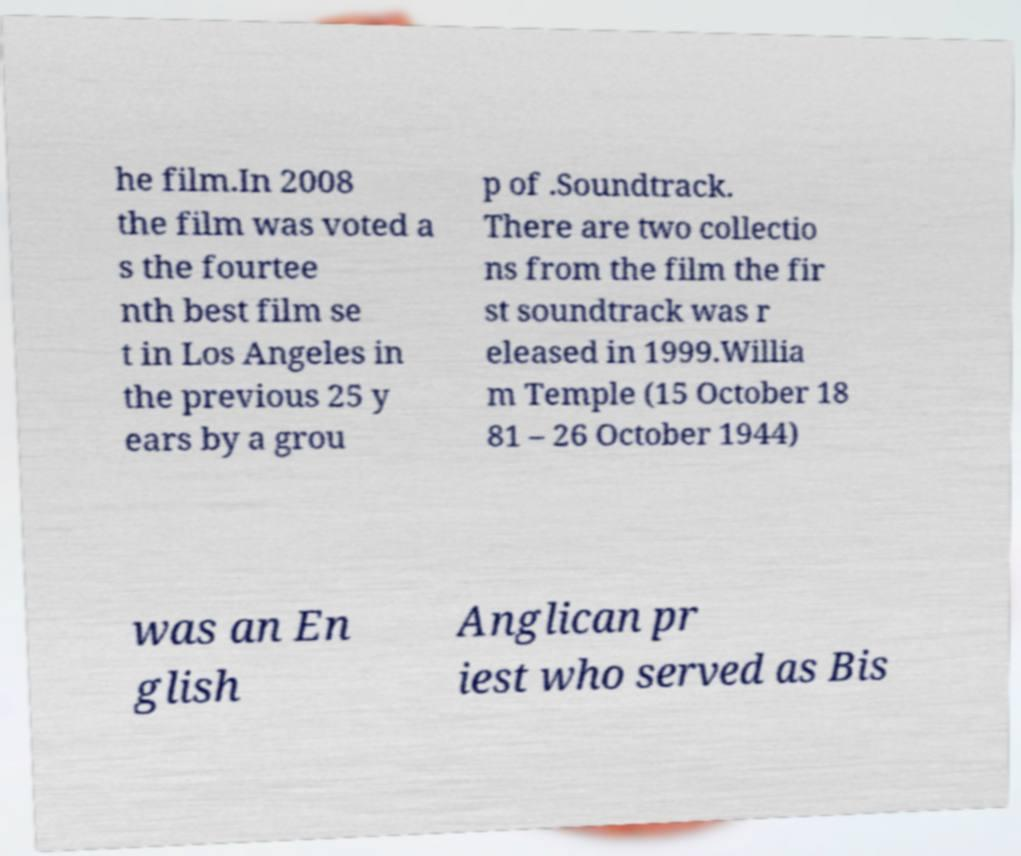For documentation purposes, I need the text within this image transcribed. Could you provide that? he film.In 2008 the film was voted a s the fourtee nth best film se t in Los Angeles in the previous 25 y ears by a grou p of .Soundtrack. There are two collectio ns from the film the fir st soundtrack was r eleased in 1999.Willia m Temple (15 October 18 81 – 26 October 1944) was an En glish Anglican pr iest who served as Bis 